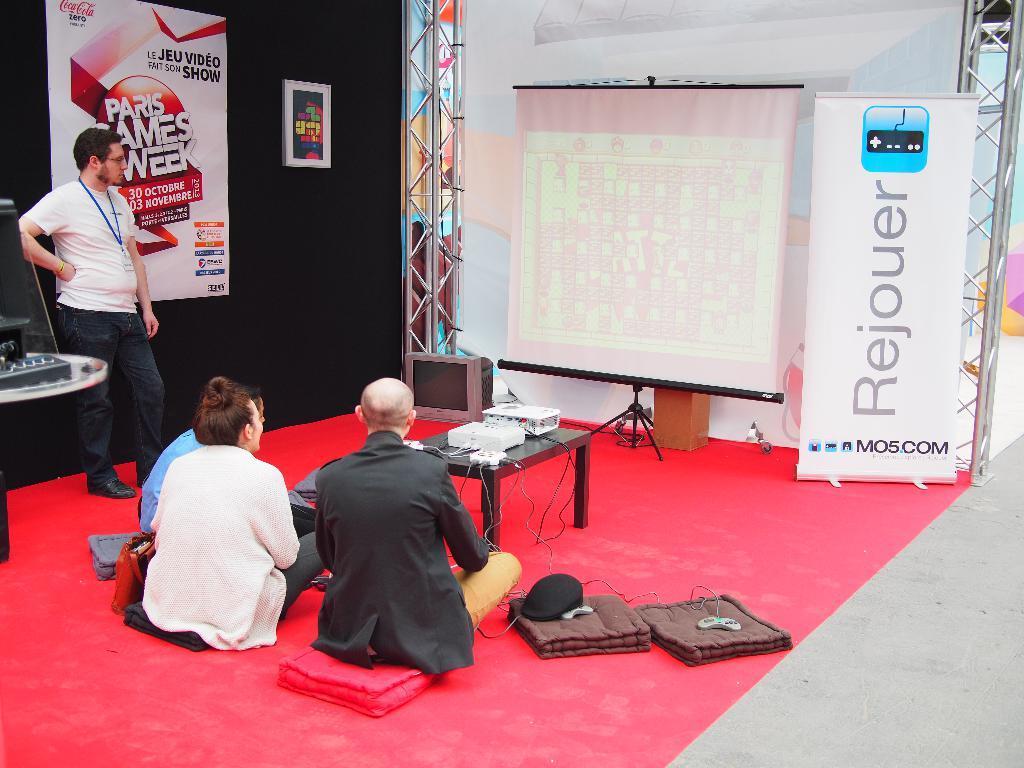How would you summarize this image in a sentence or two? In this image the man is standing and three person sitting on the floor. On the table there is a projector. In front there is a screen. 